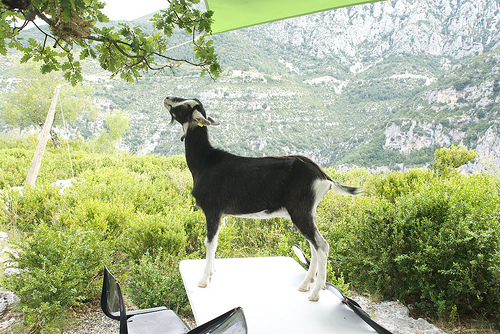<image>
Can you confirm if the chair is to the left of the table? Yes. From this viewpoint, the chair is positioned to the left side relative to the table. Where is the goat in relation to the chair? Is it above the chair? Yes. The goat is positioned above the chair in the vertical space, higher up in the scene. 